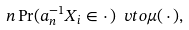<formula> <loc_0><loc_0><loc_500><loc_500>n \Pr ( a _ { n } ^ { - 1 } X _ { i } \in \cdot \, ) \ v t o \mu ( \, \cdot \, ) ,</formula> 